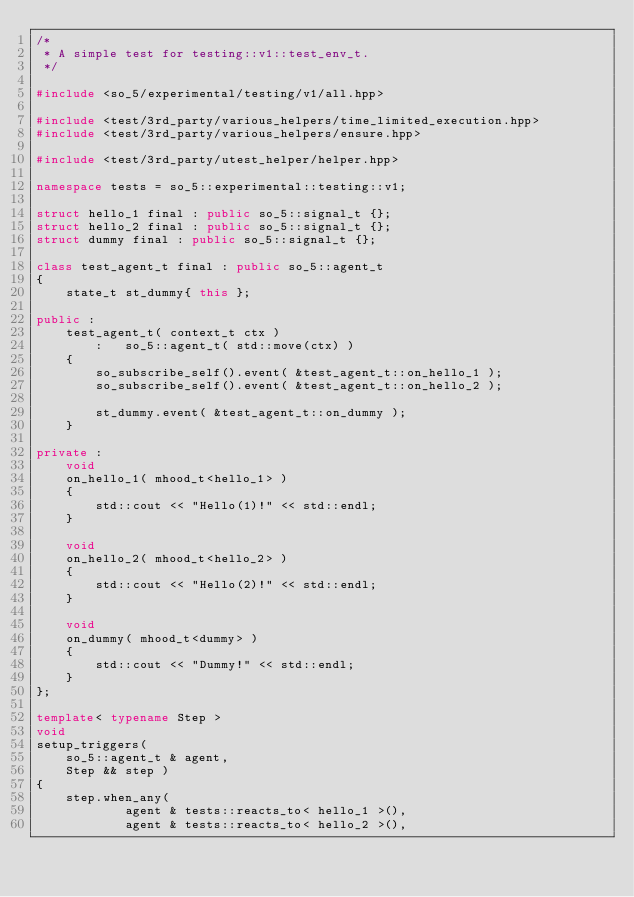<code> <loc_0><loc_0><loc_500><loc_500><_C++_>/*
 * A simple test for testing::v1::test_env_t.
 */

#include <so_5/experimental/testing/v1/all.hpp>

#include <test/3rd_party/various_helpers/time_limited_execution.hpp>
#include <test/3rd_party/various_helpers/ensure.hpp>

#include <test/3rd_party/utest_helper/helper.hpp>

namespace tests = so_5::experimental::testing::v1;

struct hello_1 final : public so_5::signal_t {};
struct hello_2 final : public so_5::signal_t {};
struct dummy final : public so_5::signal_t {};

class test_agent_t final : public so_5::agent_t
{
	state_t st_dummy{ this };

public :
	test_agent_t( context_t ctx )
		:	so_5::agent_t( std::move(ctx) )
	{
		so_subscribe_self().event( &test_agent_t::on_hello_1 );
		so_subscribe_self().event( &test_agent_t::on_hello_2 );

		st_dummy.event( &test_agent_t::on_dummy );
	}

private :
	void
	on_hello_1( mhood_t<hello_1> )
	{
		std::cout << "Hello(1)!" << std::endl;
	}

	void
	on_hello_2( mhood_t<hello_2> )
	{
		std::cout << "Hello(2)!" << std::endl;
	}

	void
	on_dummy( mhood_t<dummy> )
	{
		std::cout << "Dummy!" << std::endl;
	}
};

template< typename Step >
void
setup_triggers(
	so_5::agent_t & agent,
	Step && step )
{
	step.when_any(
			agent & tests::reacts_to< hello_1 >(),
			agent & tests::reacts_to< hello_2 >(),</code> 